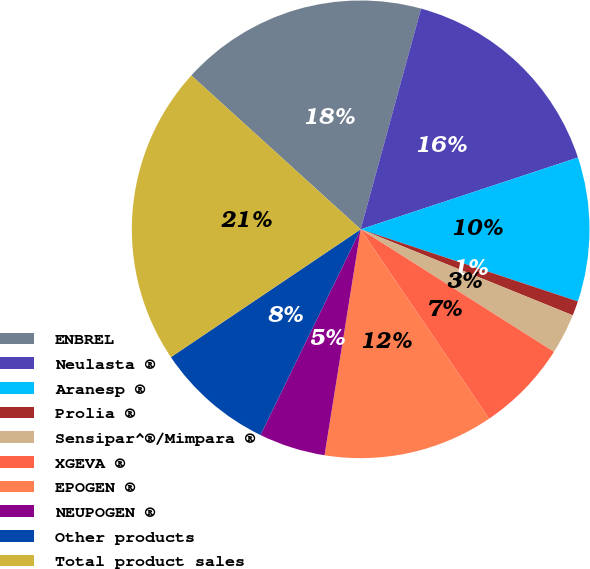Convert chart. <chart><loc_0><loc_0><loc_500><loc_500><pie_chart><fcel>ENBREL<fcel>Neulasta ®<fcel>Aranesp ®<fcel>Prolia ®<fcel>Sensipar^®/Mimpara ®<fcel>XGEVA ®<fcel>EPOGEN ®<fcel>NEUPOGEN ®<fcel>Other products<fcel>Total product sales<nl><fcel>17.51%<fcel>15.67%<fcel>10.18%<fcel>1.03%<fcel>2.86%<fcel>6.52%<fcel>12.01%<fcel>4.69%<fcel>8.35%<fcel>21.17%<nl></chart> 